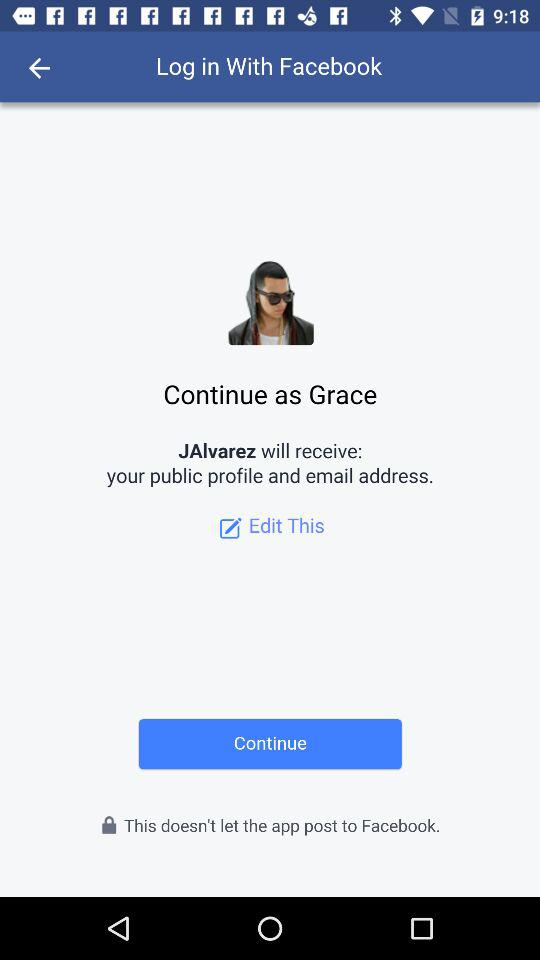Through what application can we log in? You can log in with "Facebook". 